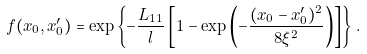<formula> <loc_0><loc_0><loc_500><loc_500>f ( x _ { 0 } , x _ { 0 } ^ { \prime } ) = \exp \left \{ - \frac { L _ { 1 1 } } { l } \left [ 1 - \exp \left ( - \frac { ( x _ { 0 } - x _ { 0 } ^ { \prime } ) ^ { 2 } } { 8 \xi ^ { 2 } } \right ) \right ] \right \} \, .</formula> 